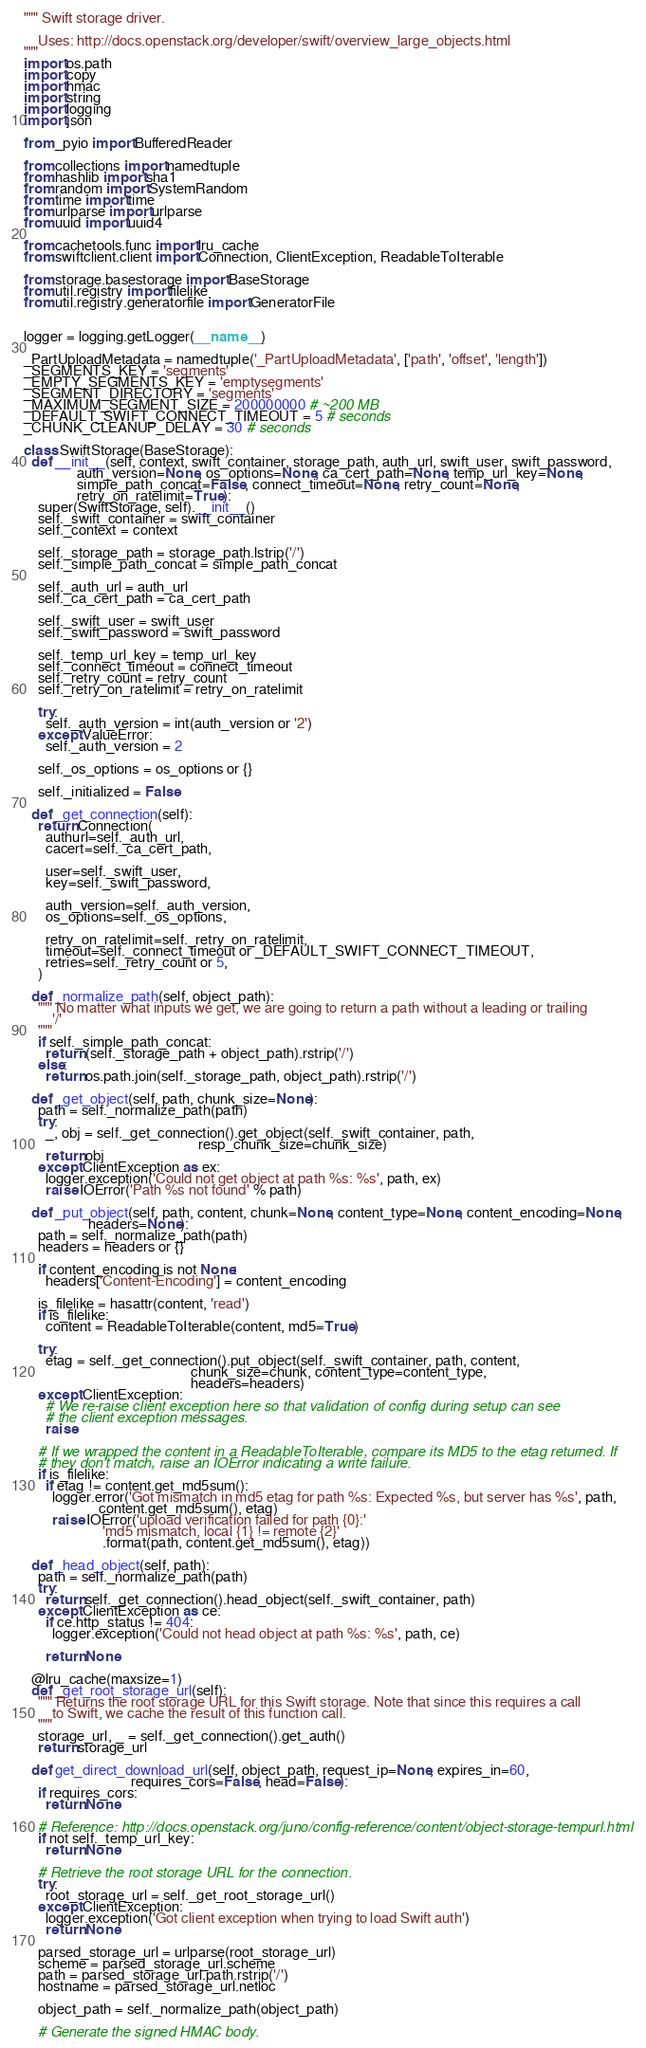<code> <loc_0><loc_0><loc_500><loc_500><_Python_>""" Swift storage driver.

    Uses: http://docs.openstack.org/developer/swift/overview_large_objects.html
"""
import os.path
import copy
import hmac
import string
import logging
import json

from _pyio import BufferedReader

from collections import namedtuple
from hashlib import sha1
from random import SystemRandom
from time import time
from urlparse import urlparse
from uuid import uuid4

from cachetools.func import lru_cache
from swiftclient.client import Connection, ClientException, ReadableToIterable

from storage.basestorage import BaseStorage
from util.registry import filelike
from util.registry.generatorfile import GeneratorFile


logger = logging.getLogger(__name__)

_PartUploadMetadata = namedtuple('_PartUploadMetadata', ['path', 'offset', 'length'])
_SEGMENTS_KEY = 'segments'
_EMPTY_SEGMENTS_KEY = 'emptysegments'
_SEGMENT_DIRECTORY = 'segments'
_MAXIMUM_SEGMENT_SIZE = 200000000 # ~200 MB
_DEFAULT_SWIFT_CONNECT_TIMEOUT = 5 # seconds
_CHUNK_CLEANUP_DELAY = 30 # seconds

class SwiftStorage(BaseStorage):
  def __init__(self, context, swift_container, storage_path, auth_url, swift_user, swift_password,
               auth_version=None, os_options=None, ca_cert_path=None, temp_url_key=None,
               simple_path_concat=False, connect_timeout=None, retry_count=None,
               retry_on_ratelimit=True):
    super(SwiftStorage, self).__init__()
    self._swift_container = swift_container
    self._context = context

    self._storage_path = storage_path.lstrip('/')
    self._simple_path_concat = simple_path_concat

    self._auth_url = auth_url
    self._ca_cert_path = ca_cert_path

    self._swift_user = swift_user
    self._swift_password = swift_password

    self._temp_url_key = temp_url_key
    self._connect_timeout = connect_timeout
    self._retry_count = retry_count
    self._retry_on_ratelimit = retry_on_ratelimit

    try:
      self._auth_version = int(auth_version or '2')
    except ValueError:
      self._auth_version = 2

    self._os_options = os_options or {}

    self._initialized = False

  def _get_connection(self):
    return Connection(
      authurl=self._auth_url,
      cacert=self._ca_cert_path,

      user=self._swift_user,
      key=self._swift_password,

      auth_version=self._auth_version,
      os_options=self._os_options,

      retry_on_ratelimit=self._retry_on_ratelimit,
      timeout=self._connect_timeout or _DEFAULT_SWIFT_CONNECT_TIMEOUT,
      retries=self._retry_count or 5,
    )

  def _normalize_path(self, object_path):
    """ No matter what inputs we get, we are going to return a path without a leading or trailing
        '/'
    """
    if self._simple_path_concat:
      return (self._storage_path + object_path).rstrip('/')
    else:
      return os.path.join(self._storage_path, object_path).rstrip('/')

  def _get_object(self, path, chunk_size=None):
    path = self._normalize_path(path)
    try:
      _, obj = self._get_connection().get_object(self._swift_container, path,
                                                 resp_chunk_size=chunk_size)
      return obj
    except ClientException as ex:
      logger.exception('Could not get object at path %s: %s', path, ex)
      raise IOError('Path %s not found' % path)

  def _put_object(self, path, content, chunk=None, content_type=None, content_encoding=None,
                  headers=None):
    path = self._normalize_path(path)
    headers = headers or {}

    if content_encoding is not None:
      headers['Content-Encoding'] = content_encoding

    is_filelike = hasattr(content, 'read')
    if is_filelike:
      content = ReadableToIterable(content, md5=True)

    try:
      etag = self._get_connection().put_object(self._swift_container, path, content,
                                               chunk_size=chunk, content_type=content_type,
                                               headers=headers)
    except ClientException:
      # We re-raise client exception here so that validation of config during setup can see
      # the client exception messages.
      raise

    # If we wrapped the content in a ReadableToIterable, compare its MD5 to the etag returned. If
    # they don't match, raise an IOError indicating a write failure.
    if is_filelike:
      if etag != content.get_md5sum():
        logger.error('Got mismatch in md5 etag for path %s: Expected %s, but server has %s', path,
                     content.get_md5sum(), etag)
        raise IOError('upload verification failed for path {0}:'
                      'md5 mismatch, local {1} != remote {2}'
                      .format(path, content.get_md5sum(), etag))

  def _head_object(self, path):
    path = self._normalize_path(path)
    try:
      return self._get_connection().head_object(self._swift_container, path)
    except ClientException as ce:
      if ce.http_status != 404:
        logger.exception('Could not head object at path %s: %s', path, ce)

      return None

  @lru_cache(maxsize=1)
  def _get_root_storage_url(self):
    """ Returns the root storage URL for this Swift storage. Note that since this requires a call
        to Swift, we cache the result of this function call.
    """
    storage_url, _ = self._get_connection().get_auth()
    return storage_url

  def get_direct_download_url(self, object_path, request_ip=None, expires_in=60,
                              requires_cors=False, head=False):
    if requires_cors:
      return None

    # Reference: http://docs.openstack.org/juno/config-reference/content/object-storage-tempurl.html
    if not self._temp_url_key:
      return None

    # Retrieve the root storage URL for the connection.
    try:
      root_storage_url = self._get_root_storage_url()
    except ClientException:
      logger.exception('Got client exception when trying to load Swift auth')
      return None

    parsed_storage_url = urlparse(root_storage_url)
    scheme = parsed_storage_url.scheme
    path = parsed_storage_url.path.rstrip('/')
    hostname = parsed_storage_url.netloc

    object_path = self._normalize_path(object_path)

    # Generate the signed HMAC body.</code> 